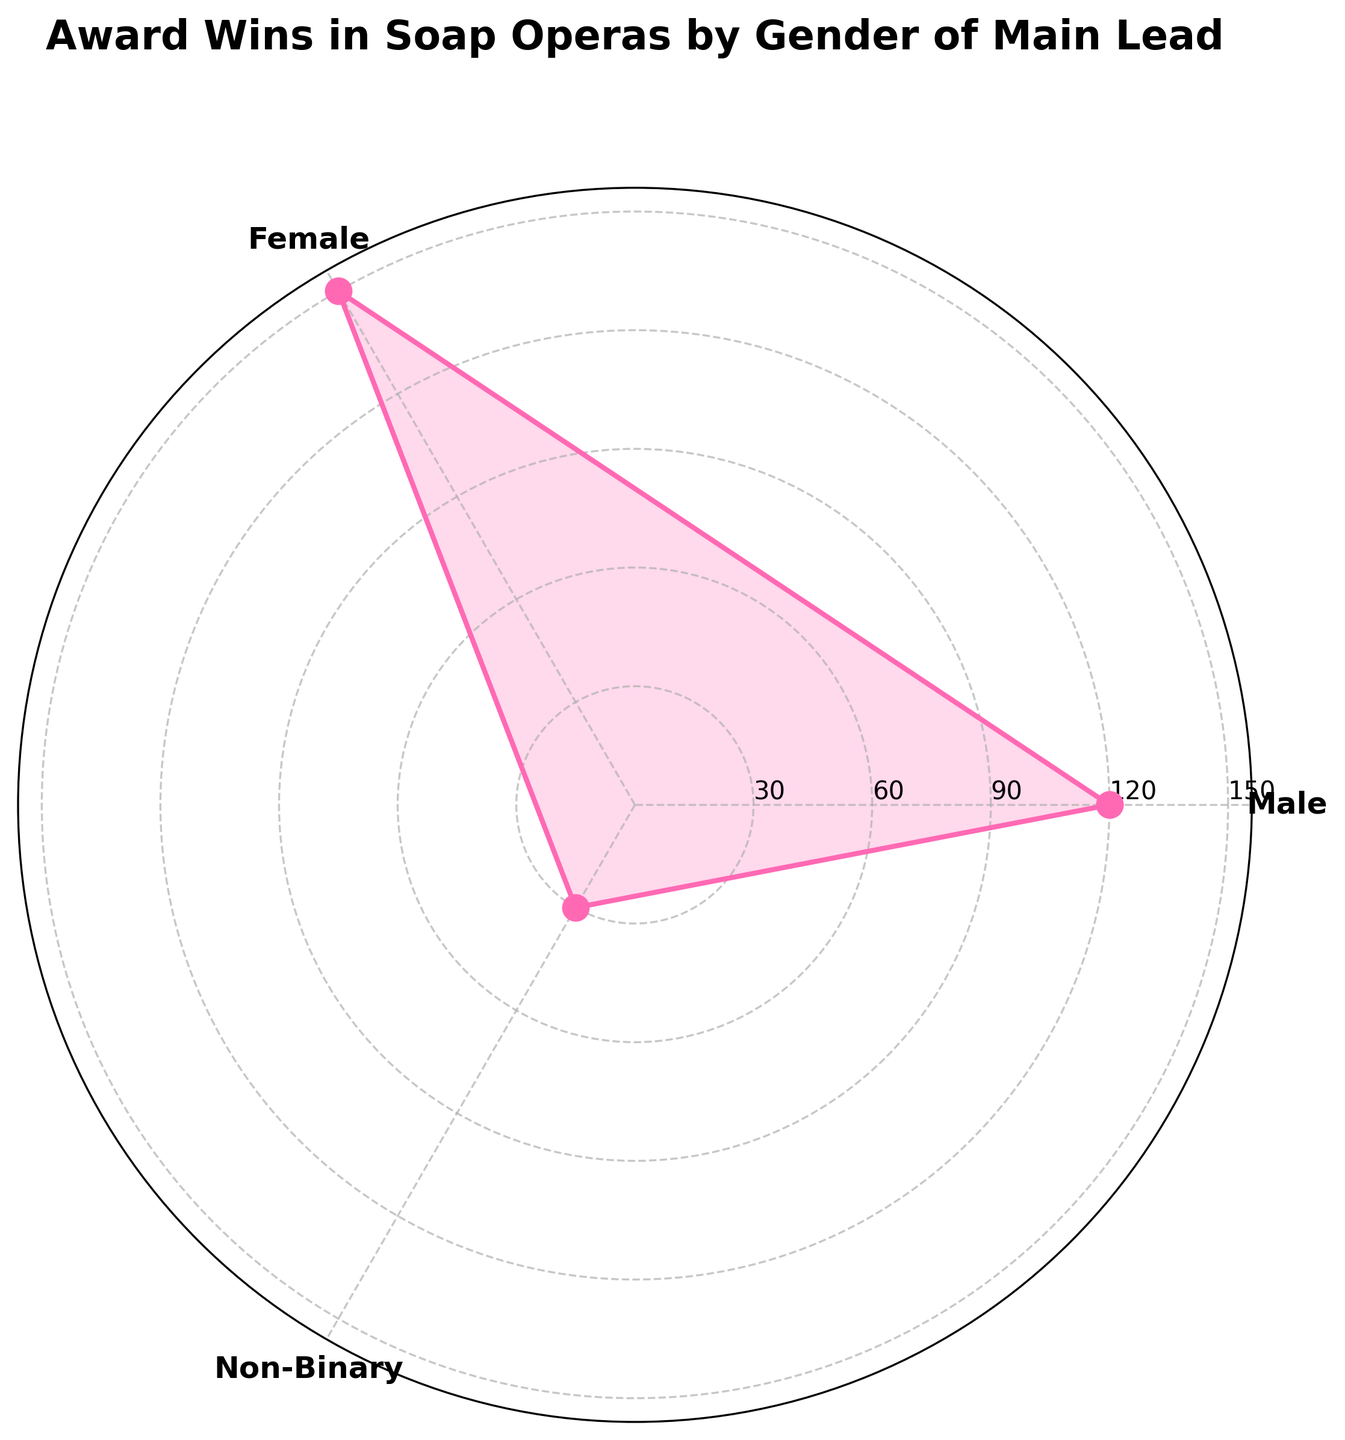What's the title of the plot? The title is displayed at the top of the plot, above the polar axes.
Answer: Award Wins in Soap Operas by Gender of Main Lead How many gender categories are represented in the plot? The categories are shown as labels around the rose chart.
Answer: 3 Which gender category has the highest number of award wins? The plot lines and areas show that the "Female" category extends the furthest from the center, indicating the highest number of award wins.
Answer: Female What is the number of award wins for the Non-Binary category? One of the radial ticks aligns with the length of the plot line for "Non-Binary," showing the number of award wins.
Answer: 30 How many more award wins does the Female category have compared to the Male category? Subtract the number of wins for Male (120) from the number of wins for Female (150).
Answer: 30 Which category has the fewest award wins? The category whose plot line is closest to the center of the rose chart has the fewest wins.
Answer: Non-Binary What are the radial tick intervals, and how do they help interpret the figure? The radial ticks are spaced at 30 award wins each, helping to visualize the number of award wins for each category.
Answer: 30 How many data points are plotted in the rose chart? Each gender category represents one data point, making it simple to count the total number of data points.
Answer: 3 By how much does the number of award wins for the Male category exceed that for the Non-Binary category? Subtract the number of wins for Non-Binary (30) from the number of wins for Male (120).
Answer: 90 